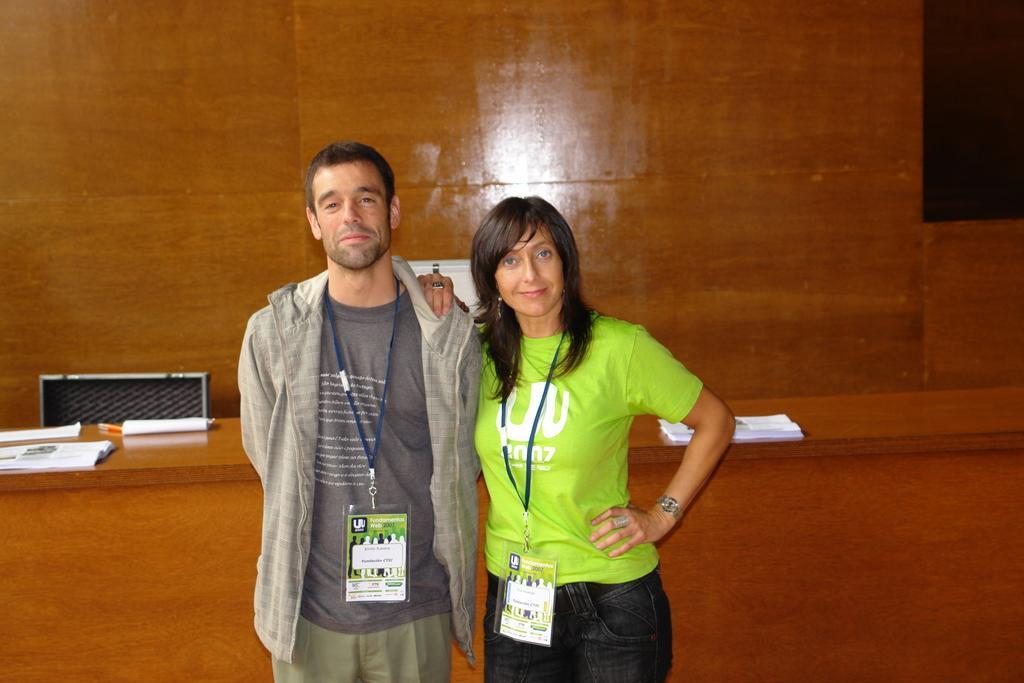In one or two sentences, can you explain what this image depicts? In the middle of the image two persons are standing and smiling. Behind them there is a table, on the table there are some papers and pens. At the top of the image there is wall. 